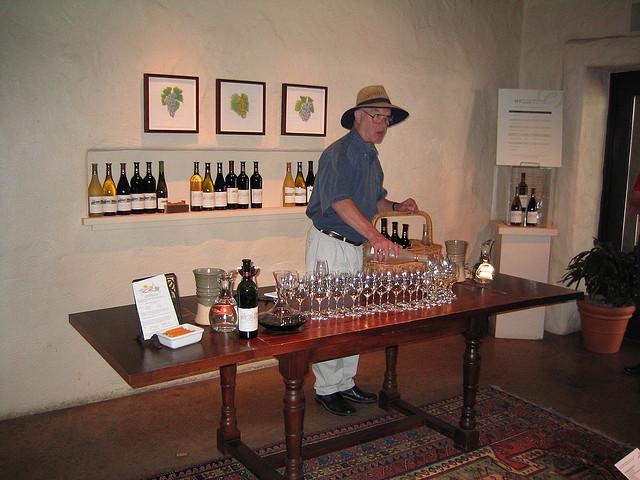How many bunches of grapes?
Be succinct. 0. Are there a lot of people?
Short answer required. No. What item is in front of the painting?
Quick response, please. Wine. Is he listening to music?
Quick response, please. No. Would this person better be suited with a ottoman?
Be succinct. No. Is there an Asian painting?
Be succinct. No. Are they ready to have dinner?
Short answer required. No. What are they serving?
Answer briefly. Wine. What is in the center of the table?
Concise answer only. Glasses. Is the person wearing a ball cap?
Concise answer only. No. What are the people about to eat?
Write a very short answer. Wine. Is this in a library?
Give a very brief answer. No. What game system is the man standing up playing?
Short answer required. None. 